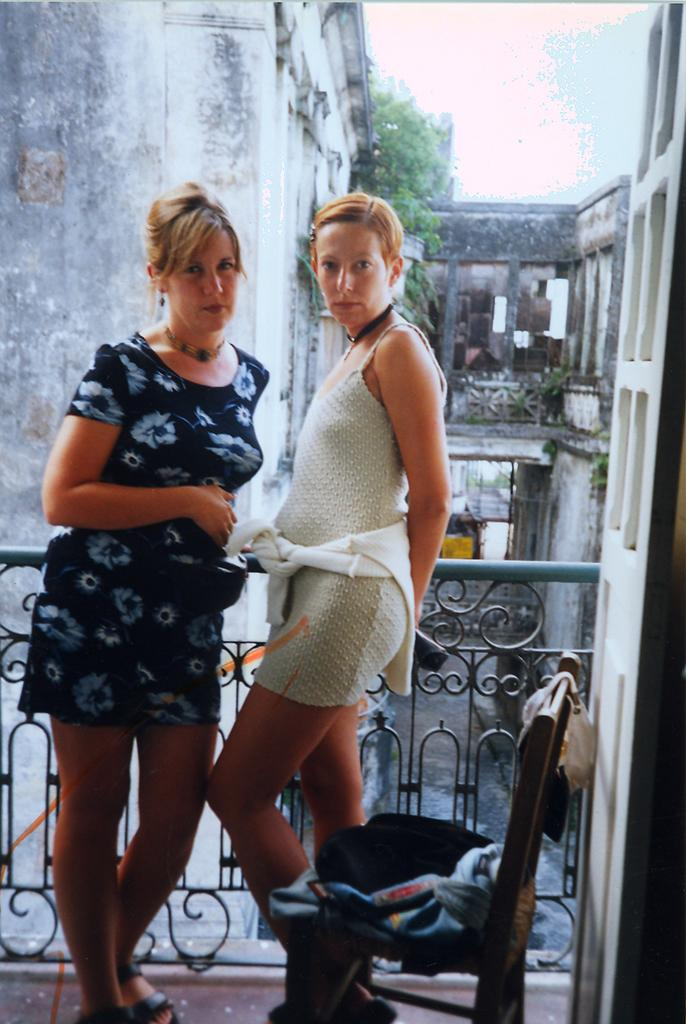How many women are present in the image? There are two women standing in the image. What can be seen in the background of the image? The sky is visible in the background of the image. What is the purpose of the fence in the image? The purpose of the fence is not specified in the image. What is the chair in the image being used for? The chair has clothes on it, suggesting it might be used for storage or drying clothes. What type of structures can be seen in the image? There are buildings in the image. What other objects are present in the image? There are some unspecified objects in the image. What type of grain is being harvested in the image? There is no grain or harvesting activity present in the image. What kind of club is visible in the image? There is no club present in the image. 